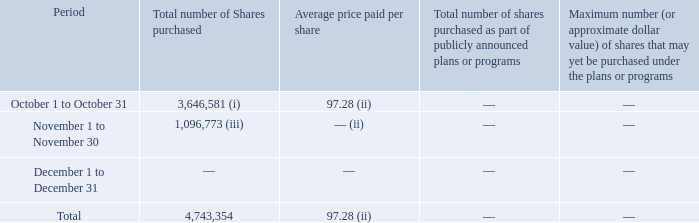Issuer Purchases of Equity Securities
(i) Includes 3,416 shares that have been withheld by the Company to satisfy its tax withholding and remittance obligations in connection with the vesting of restricted stock awards. In addition, the Company exercised a pro-rata portion of the 2022 convertible note hedges (described in Note 12, Indebtedness, of the Notes to the Consolidated Financial Statements) to offset the shares of the Company’s Class A common stock issued to settle the conversion of certain 2022 Notes. The note hedges were net share settled and the Company received 3,643,165 shares of the Company’s Class A common stock from the counterparties in October of 2018.
(ii) Excludes the shares received through the exercise of the note hedges.
(iii) The Company exercised a pro-rata portion of the 2022 convertible note hedges to offset the shares of the Company’s Class A common stock issued to settle the conversion of certain 2022 Notes. The note hedges were net share settled and the Company received 1,096,773 shares of the Company’s Class A common stock from the counterparties in November of 2018.
What are the months provided in the period column? October, november, december. What is the Total number of Shares purchased across the periods? 4,743,354. How many shares did the company receive from Company’s Class A common stock from the counterparties in November of 2018? 1,096,773. What is the percentage amount of the number of shares purchased in October?
Answer scale should be: percent. 3,646,581 / 4,743,354 
Answer: 76.88. What is the average total number of shares purchased? (3,646,581 + 1,096,773) / 3 
Answer: 1581118. Which period has the largest number of shares purchased?   From COL3 look for the largest number and find the corresponding period in COL2 
Answer: october 1 to october 31. 